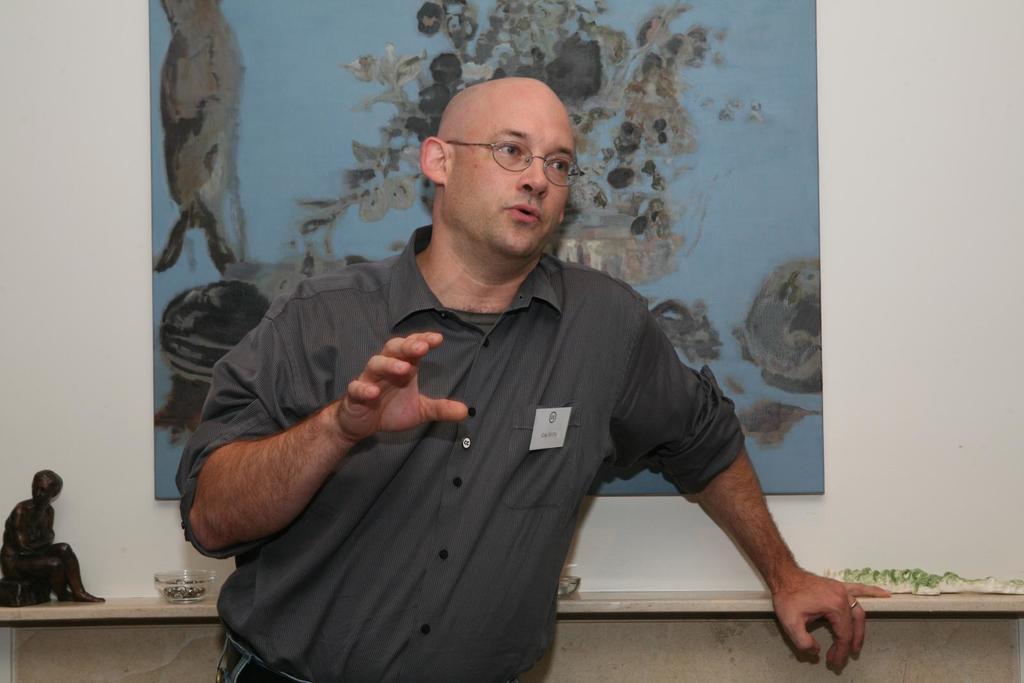Can you describe this image briefly? In this image in the front there is a person standing and speaking. In the background there is a frame on the wall and in front of the wall there are objects which are black and white in colour and there are bowls. 